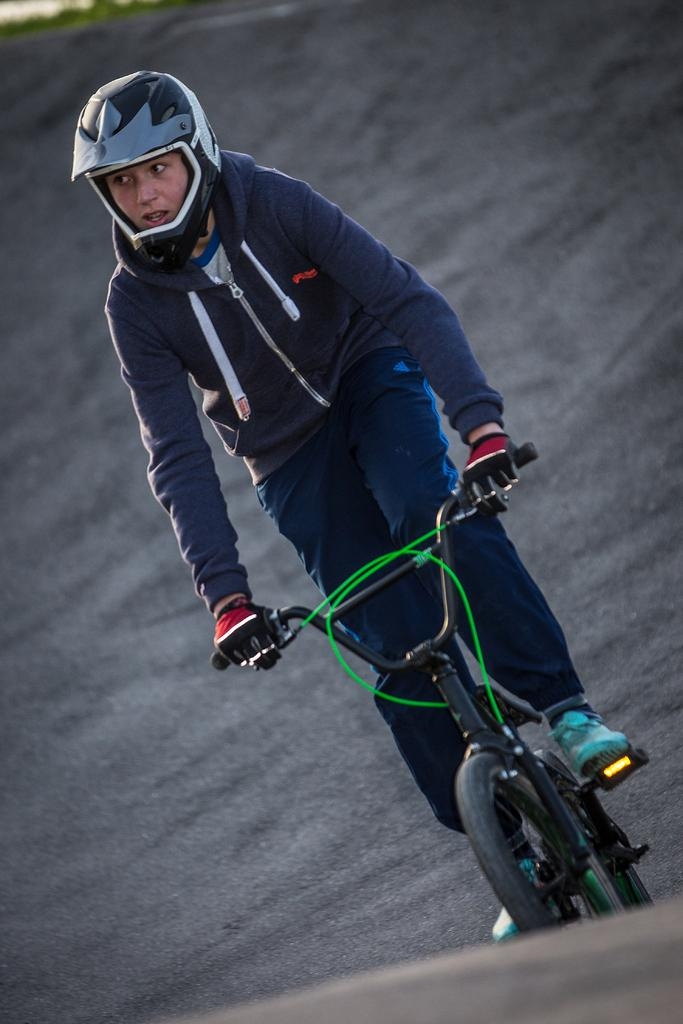What is the main subject of the image? There is a person riding a bicycle in the image. Where is the bicycle located in the image? The bicycle is in the center of the image. What is visible at the bottom of the image? There is a road at the bottom of the image. How many screws can be seen holding the apple to the hand in the image? There is no apple or hand present in the image, and therefore no screws can be observed. 